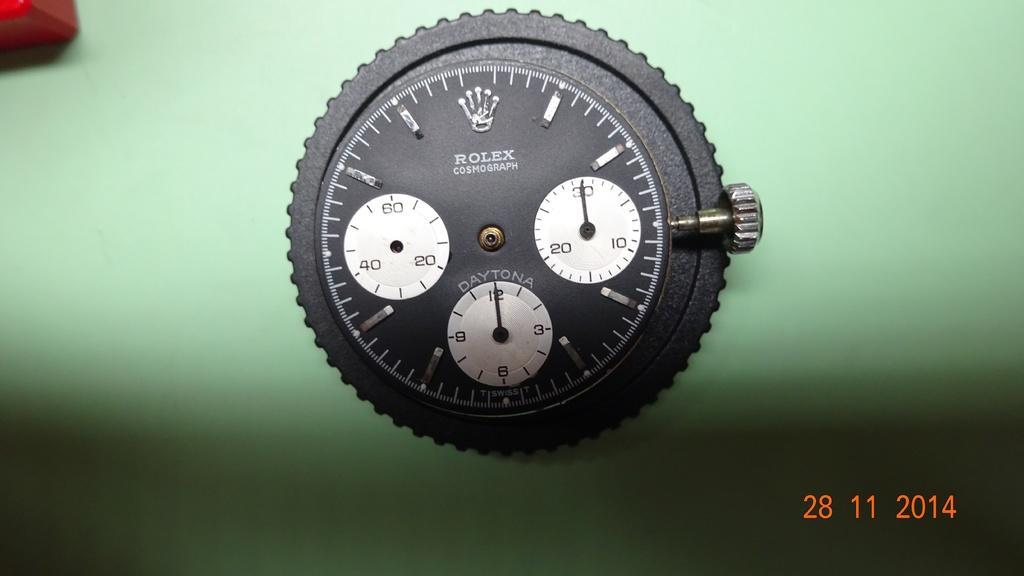Can you describe this image briefly? In this image I can see a watch part, numbers and green color background. This image looks like an edited photo. 